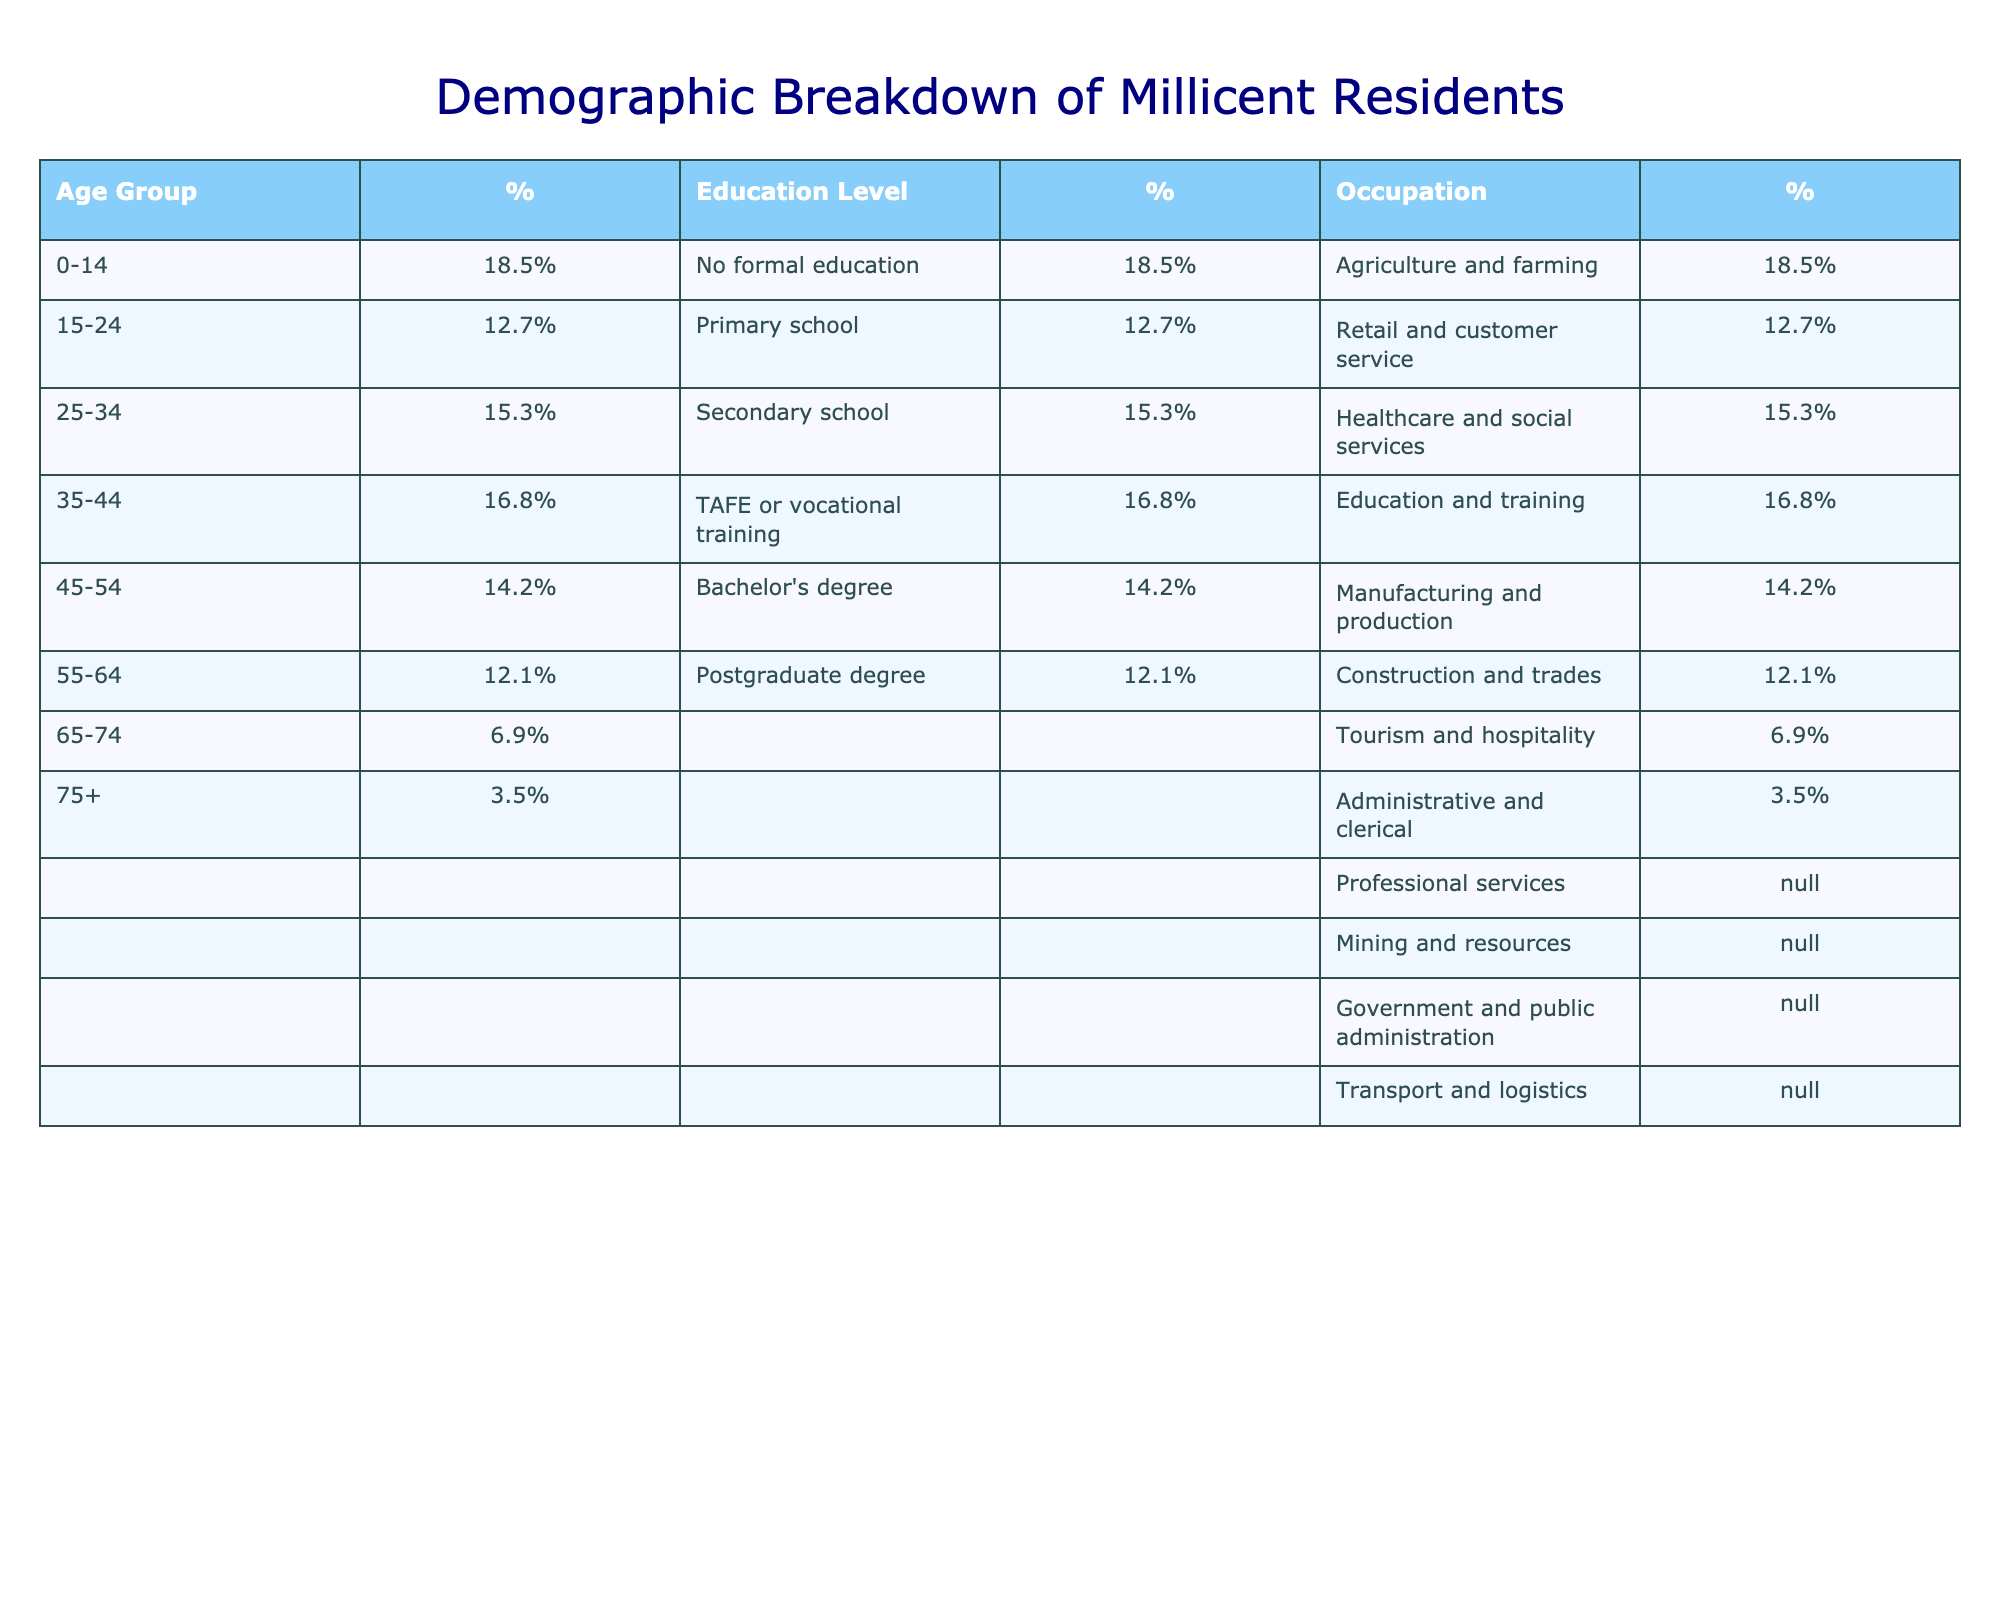What percentage of Millicent residents are aged 0-14? According to the table, the percentage of residents aged 0-14 is listed next to the age group label, which is 18.5%.
Answer: 18.5% What educational attainment level has the highest percentage among Millicent residents? By examining the education level percentages, Secondary school has the highest figure, at 38.2%.
Answer: Secondary school Which occupation has the lowest representation among Millicent residents? The occupation data shows that Mining and resources has the lowest percentage at 3.6%.
Answer: Mining and resources What percentage of residents aged 55-64 have a postgraduate degree? The table indicates that 4.8% of residents aged 55-64 have a postgraduate degree.
Answer: 4.8% What is the combined percentage of Millicent residents who are aged 65 and older? To find this, we add the percentages of the age groups 65-74 (6.9%) and 75+ (3.5%), giving a total of 6.9% + 3.5% = 10.4%.
Answer: 10.4% How many age groups exceed 15% of the population in Millicent? We check the age groups listed: 0-14 (18.5%), 25-34 (15.3%), 35-44 (16.8%), and 45-54 (14.2%). The groups that exceed 15% are 0-14, 25-34, and 35-44, which makes for a total of 3 age groups.
Answer: 3 Is it true that more than half of the residents have a Bachelor's degree? By looking at the percentage for Bachelor's degree, which is 14.8%, and knowing the total percentage for all education levels must equal 100%, we can conclude that no, it is not true that more than half have a Bachelor's degree.
Answer: No What is the difference in percentage between the highest and lowest education levels? The highest percentage for education (Secondary school) is 38.2%, while the lowest (No formal education) is 2.1%. The difference is 38.2% - 2.1% = 36.1%.
Answer: 36.1% Which occupation has a higher percentage: Healthcare and social services or Administrative and clerical? Healthcare and social services has a percentage of 12.5%, while Administrative and clerical has 4.8%. Comparing these values shows that 12.5% is greater than 4.8%, so Healthcare and social services has the higher percentage.
Answer: Healthcare and social services What percentage of the residents working in Agriculture and farming have no formal education? The table shows that 22.3% work in Agriculture and farming and only 2.1% have no formal education, but does not establish a direct correlation between the two groups. Thus, specific overlap information cannot be derived.
Answer: Not determinable from table 